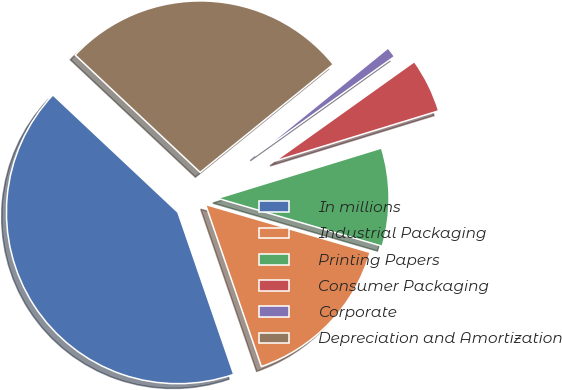Convert chart to OTSL. <chart><loc_0><loc_0><loc_500><loc_500><pie_chart><fcel>In millions<fcel>Industrial Packaging<fcel>Printing Papers<fcel>Consumer Packaging<fcel>Corporate<fcel>Depreciation and Amortization<nl><fcel>42.28%<fcel>15.21%<fcel>9.25%<fcel>5.12%<fcel>0.99%<fcel>27.15%<nl></chart> 